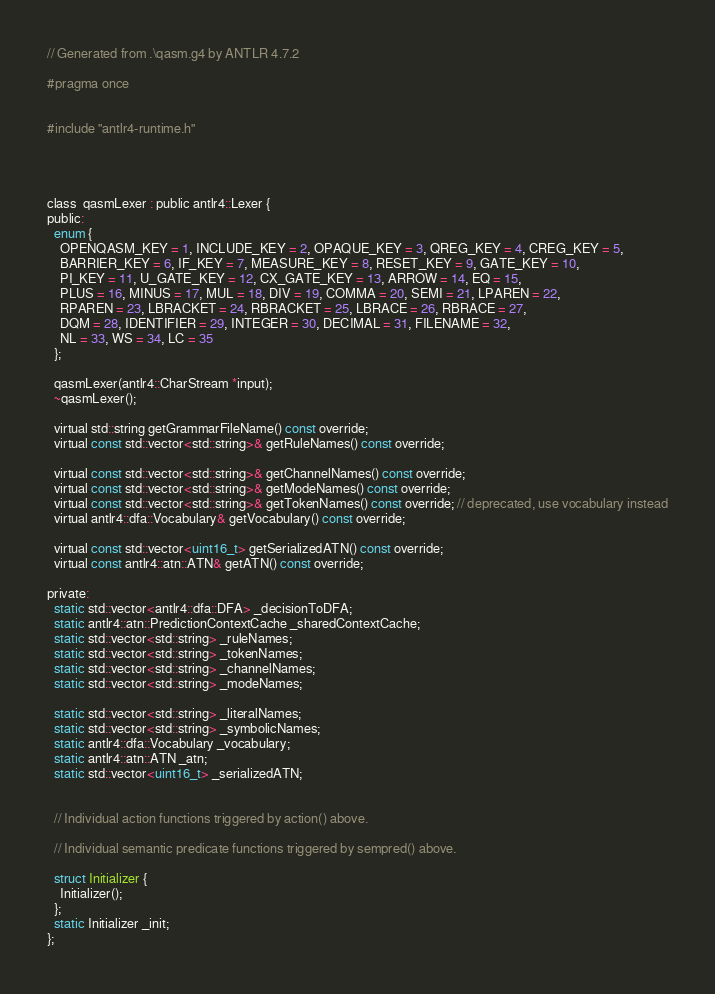<code> <loc_0><loc_0><loc_500><loc_500><_C_>
// Generated from .\qasm.g4 by ANTLR 4.7.2

#pragma once


#include "antlr4-runtime.h"




class  qasmLexer : public antlr4::Lexer {
public:
  enum {
    OPENQASM_KEY = 1, INCLUDE_KEY = 2, OPAQUE_KEY = 3, QREG_KEY = 4, CREG_KEY = 5, 
    BARRIER_KEY = 6, IF_KEY = 7, MEASURE_KEY = 8, RESET_KEY = 9, GATE_KEY = 10, 
    PI_KEY = 11, U_GATE_KEY = 12, CX_GATE_KEY = 13, ARROW = 14, EQ = 15, 
    PLUS = 16, MINUS = 17, MUL = 18, DIV = 19, COMMA = 20, SEMI = 21, LPAREN = 22, 
    RPAREN = 23, LBRACKET = 24, RBRACKET = 25, LBRACE = 26, RBRACE = 27, 
    DQM = 28, IDENTIFIER = 29, INTEGER = 30, DECIMAL = 31, FILENAME = 32, 
    NL = 33, WS = 34, LC = 35
  };

  qasmLexer(antlr4::CharStream *input);
  ~qasmLexer();

  virtual std::string getGrammarFileName() const override;
  virtual const std::vector<std::string>& getRuleNames() const override;

  virtual const std::vector<std::string>& getChannelNames() const override;
  virtual const std::vector<std::string>& getModeNames() const override;
  virtual const std::vector<std::string>& getTokenNames() const override; // deprecated, use vocabulary instead
  virtual antlr4::dfa::Vocabulary& getVocabulary() const override;

  virtual const std::vector<uint16_t> getSerializedATN() const override;
  virtual const antlr4::atn::ATN& getATN() const override;

private:
  static std::vector<antlr4::dfa::DFA> _decisionToDFA;
  static antlr4::atn::PredictionContextCache _sharedContextCache;
  static std::vector<std::string> _ruleNames;
  static std::vector<std::string> _tokenNames;
  static std::vector<std::string> _channelNames;
  static std::vector<std::string> _modeNames;

  static std::vector<std::string> _literalNames;
  static std::vector<std::string> _symbolicNames;
  static antlr4::dfa::Vocabulary _vocabulary;
  static antlr4::atn::ATN _atn;
  static std::vector<uint16_t> _serializedATN;


  // Individual action functions triggered by action() above.

  // Individual semantic predicate functions triggered by sempred() above.

  struct Initializer {
    Initializer();
  };
  static Initializer _init;
};

</code> 